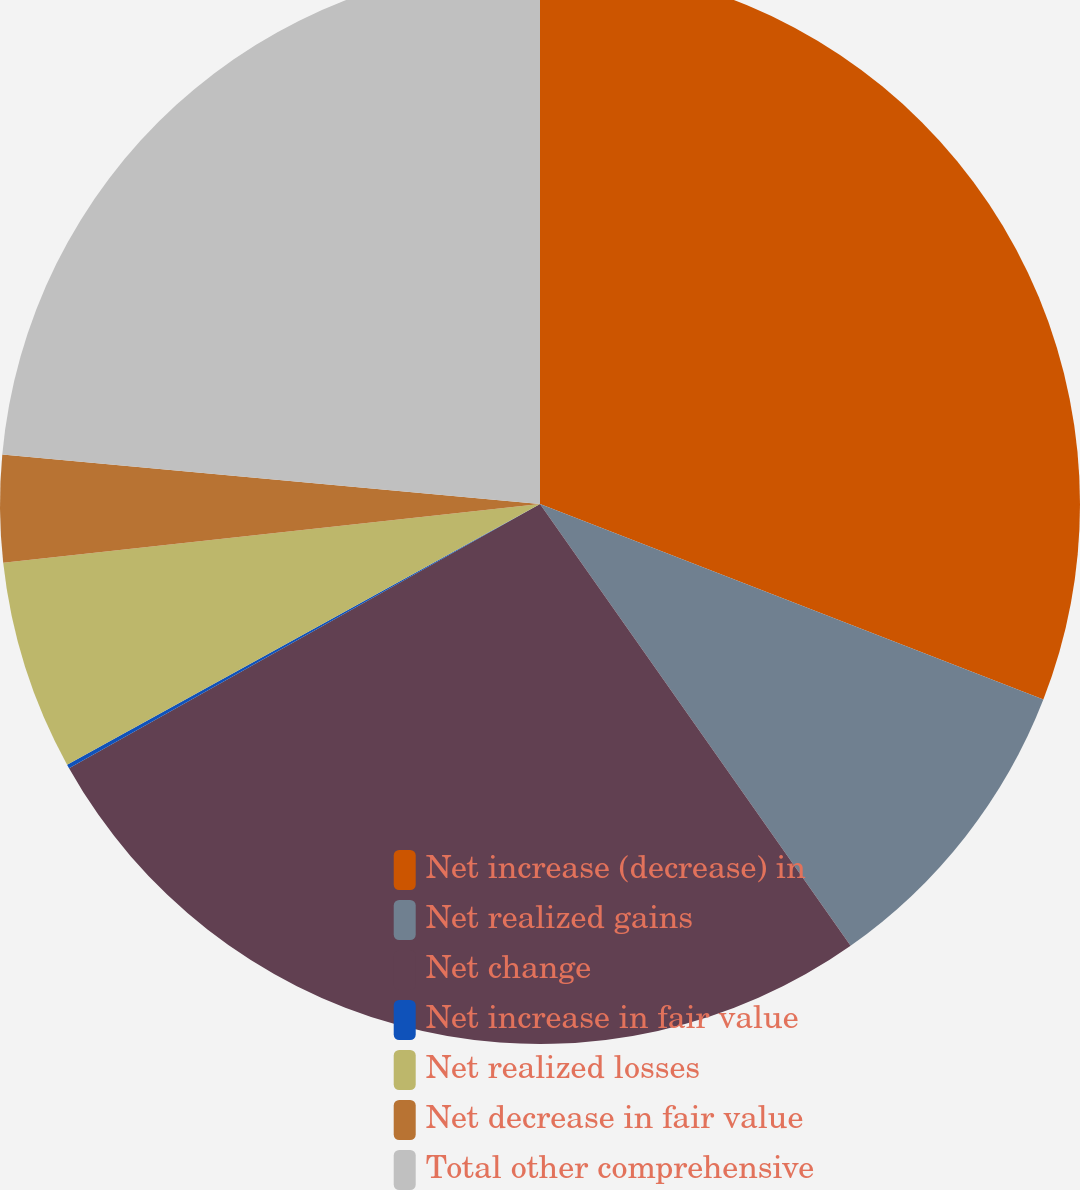Convert chart to OTSL. <chart><loc_0><loc_0><loc_500><loc_500><pie_chart><fcel>Net increase (decrease) in<fcel>Net realized gains<fcel>Net change<fcel>Net increase in fair value<fcel>Net realized losses<fcel>Net decrease in fair value<fcel>Total other comprehensive<nl><fcel>30.9%<fcel>9.35%<fcel>26.62%<fcel>0.12%<fcel>6.28%<fcel>3.2%<fcel>23.54%<nl></chart> 